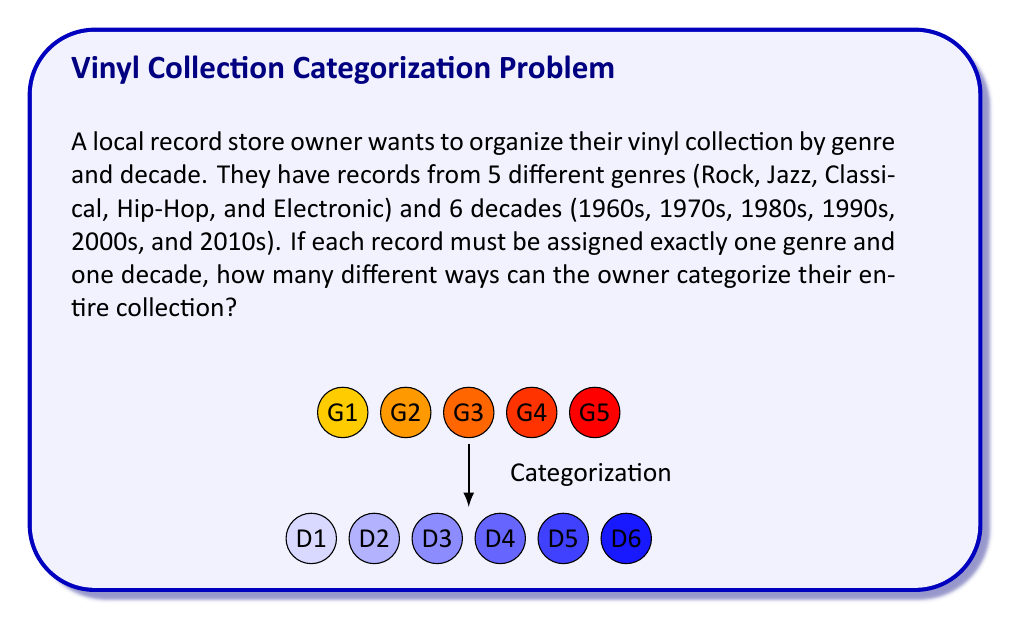Provide a solution to this math problem. Let's approach this step-by-step:

1) For each record, we need to make two independent choices:
   - Choose a genre (out of 5 options)
   - Choose a decade (out of 6 options)

2) According to the Multiplication Principle, when we have to make multiple independent choices, we multiply the number of options for each choice.

3) So, for a single record, the number of ways to categorize it is:
   $$ 5 \text{ (genres)} \times 6 \text{ (decades)} = 30 $$

4) However, the question asks about categorizing the entire collection. This means we're not just categorizing one record, but creating a system where any record could potentially fall into any of these 30 categories.

5) In combinatorics, when we're dealing with the number of ways to create categories or partitions, we're essentially looking at the number of functions from the set of records to the set of categories.

6) The number of such functions is given by $m^n$, where $m$ is the number of categories and $n$ is the number of items being categorized.

7) In this case, we have 30 categories (5 genres × 6 decades), and we're categorizing the entire collection (which could contain any number of records).

8) Therefore, the number of ways to categorize the entire collection is:

   $$ 30^n $$

   where $n$ is the total number of records in the collection.

9) Since we don't know the exact number of records, we can leave our answer in this form.
Answer: $30^n$, where $n$ is the number of records in the collection. 